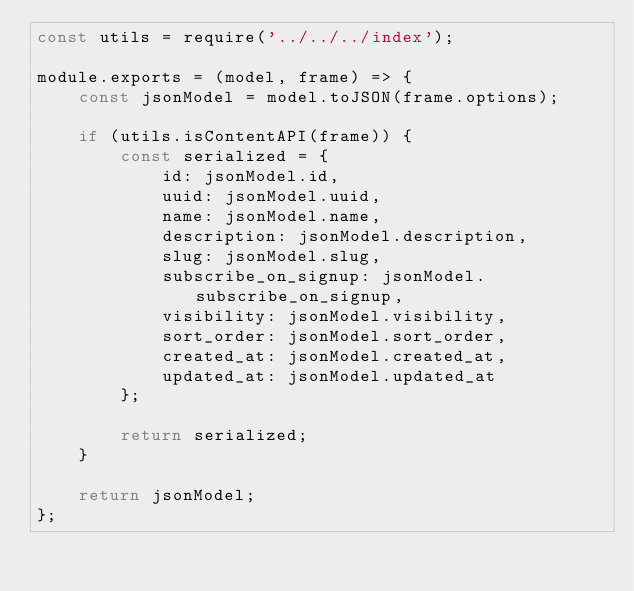Convert code to text. <code><loc_0><loc_0><loc_500><loc_500><_JavaScript_>const utils = require('../../../index');

module.exports = (model, frame) => {
    const jsonModel = model.toJSON(frame.options);

    if (utils.isContentAPI(frame)) {
        const serialized = {
            id: jsonModel.id,
            uuid: jsonModel.uuid,
            name: jsonModel.name,
            description: jsonModel.description,
            slug: jsonModel.slug,
            subscribe_on_signup: jsonModel.subscribe_on_signup,
            visibility: jsonModel.visibility,
            sort_order: jsonModel.sort_order,
            created_at: jsonModel.created_at,
            updated_at: jsonModel.updated_at
        };

        return serialized;
    }

    return jsonModel;
};
</code> 